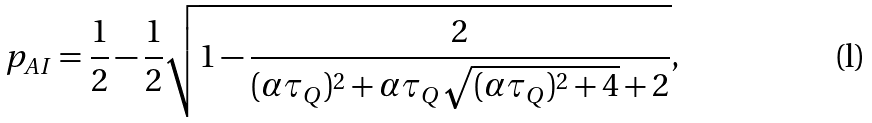<formula> <loc_0><loc_0><loc_500><loc_500>p _ { A I } = \frac { 1 } { 2 } - \frac { 1 } { 2 } \sqrt { 1 - \frac { 2 } { ( \alpha \tau _ { Q } ) ^ { 2 } + \alpha \tau _ { Q } \sqrt { ( \alpha \tau _ { Q } ) ^ { 2 } + 4 } + 2 } } ,</formula> 